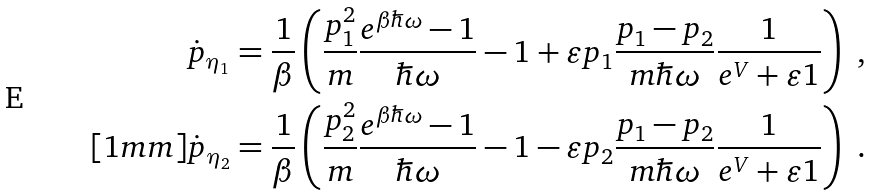Convert formula to latex. <formula><loc_0><loc_0><loc_500><loc_500>\dot { p } _ { \eta _ { 1 } } & = \frac { 1 } { \beta } \left ( \frac { p _ { 1 } ^ { 2 } } { m } \frac { e ^ { \beta \hbar { \omega } } - 1 } { \hbar { \omega } } - 1 + \varepsilon p _ { 1 } \frac { p _ { 1 } - p _ { 2 } } { m \hbar { \omega } } \frac { 1 } { e ^ { V } + \varepsilon 1 } \right ) \ , \\ [ 1 m m ] \dot { p } _ { \eta _ { 2 } } & = \frac { 1 } { \beta } \left ( \frac { p _ { 2 } ^ { 2 } } { m } \frac { e ^ { \beta \hbar { \omega } } - 1 } { \hbar { \omega } } - 1 - \varepsilon p _ { 2 } \frac { p _ { 1 } - p _ { 2 } } { m \hbar { \omega } } \frac { 1 } { e ^ { V } + \varepsilon 1 } \right ) \ .</formula> 